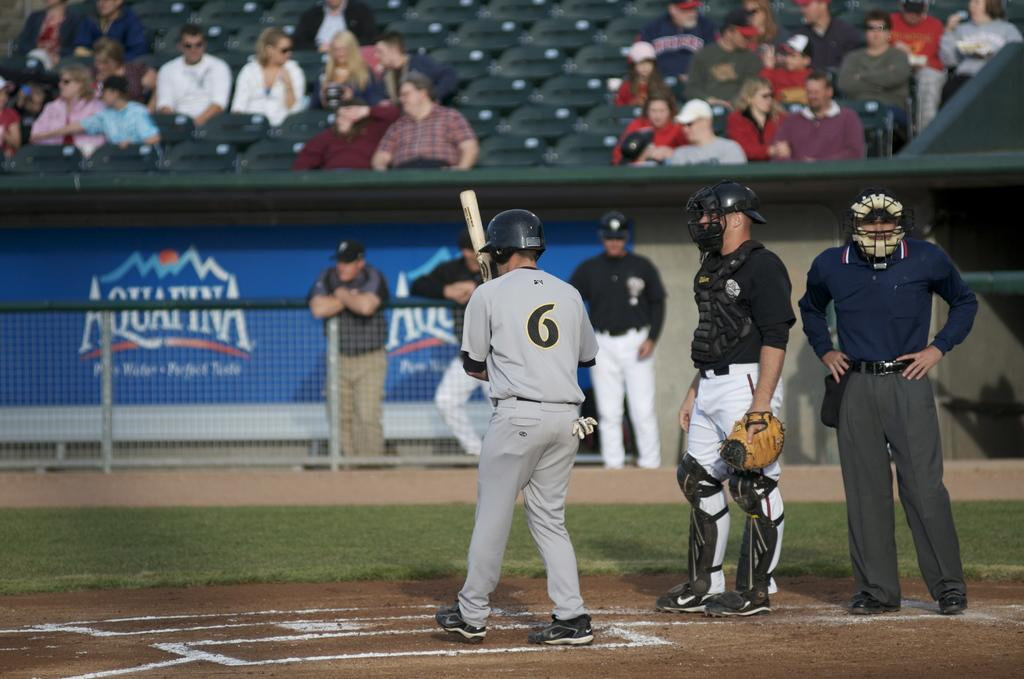<image>
Create a compact narrative representing the image presented. A batter stands at the mound across from an Aquafina logo on the stadium wall. 